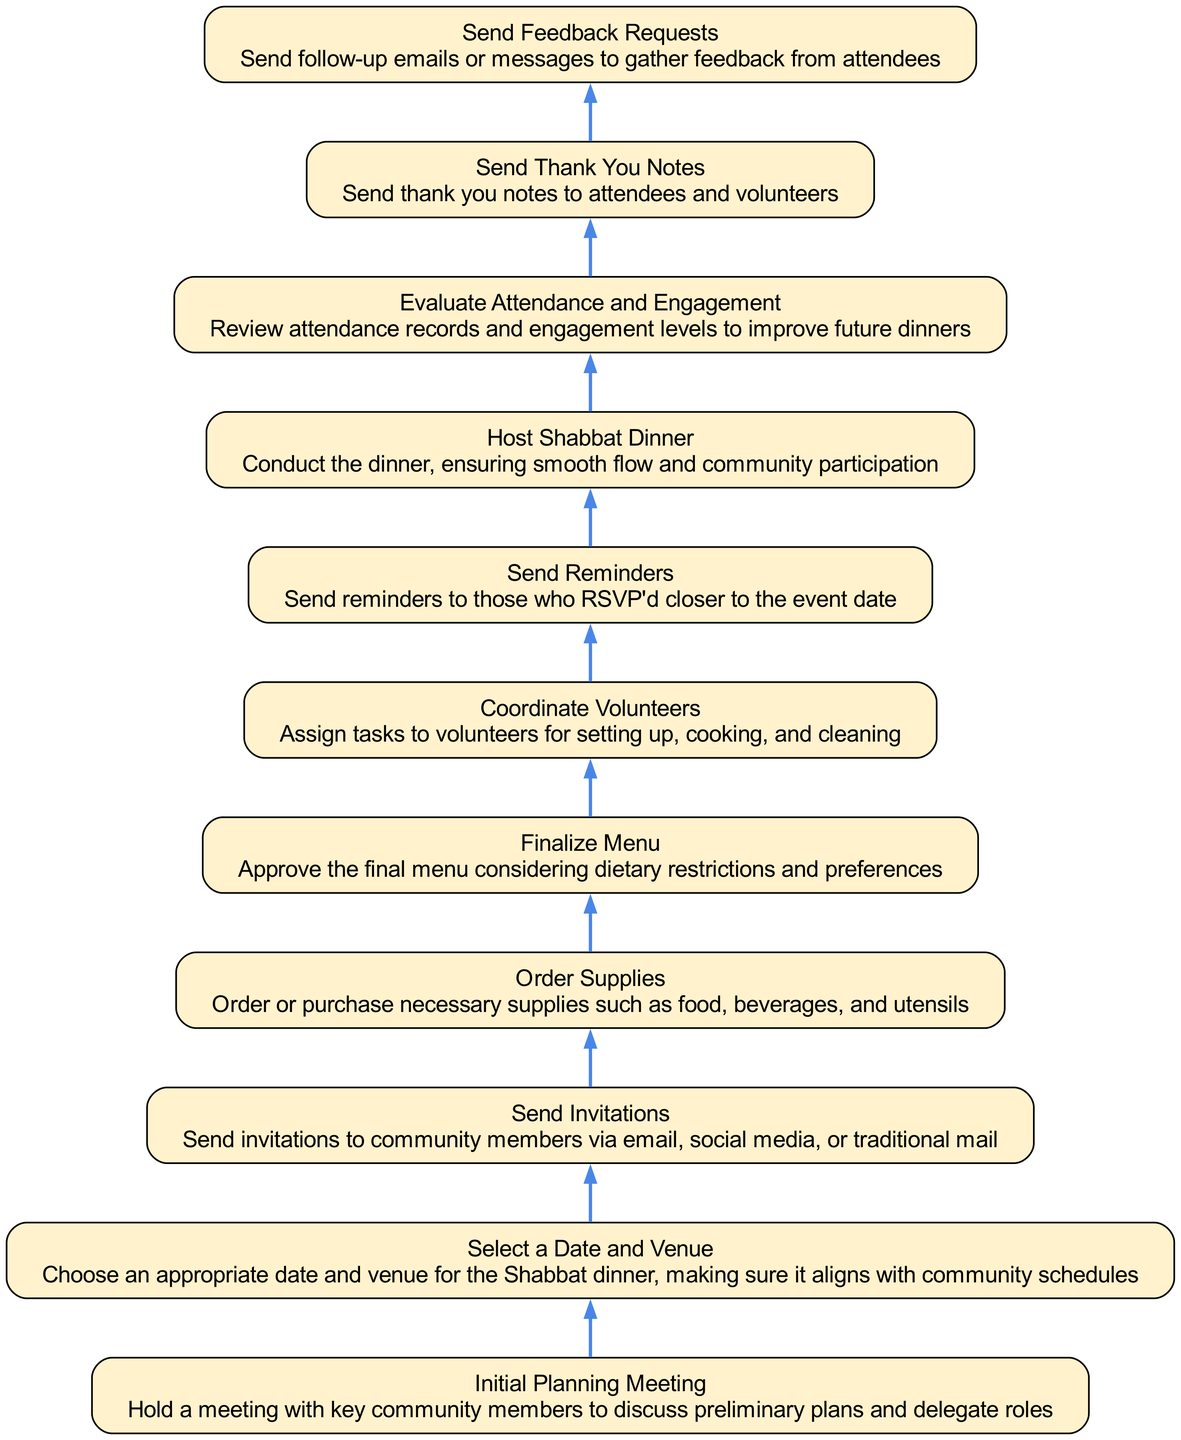What is the first step in the Shabbat Dinner coordination process? The diagram starts with the node "Initial Planning Meeting," which indicates that this is the first step before any other actions can take place.
Answer: Initial Planning Meeting How many nodes are there in total? By counting each unique step listed in the flowchart, there are a total of eleven nodes.
Answer: Eleven What step follows "Send Invitations"? According to the flowchart, "Send Invitations" is followed by "Select a Date and Venue," indicating the next action to take in the process.
Answer: Select a Date and Venue What is the relationship between "Host Shabbat Dinner" and "Send Reminders"? The flowchart shows a directional edge from "Host Shabbat Dinner" to "Send Reminders," indicating that reminders are sent after hosting the dinner.
Answer: Followed by Which step comes after "Order Supplies"? "Order Supplies" leads directly to "Send Invitations," as indicated by the directional flow from one step to the next in the diagram.
Answer: Send Invitations What is the endpoint of the flowchart? The flowchart ends with the node "Initial Planning Meeting," which does not have a subsequent step that follows it, making it the final action in this process.
Answer: Initial Planning Meeting What action is taken to improve future dinners? "Evaluate Attendance and Engagement" is the action taken to gather insights from previous events to enhance future Shabbat dinners.
Answer: Evaluate Attendance and Engagement What task is associated with "Coordinate Volunteers"? "Coordinate Volunteers" involves assigning specific tasks such as setting up, cooking, and cleaning for the Shabbat dinner, as indicated in the node description.
Answer: Assign tasks What does "Send Thank You Notes" follow? The diagram shows that "Send Thank You Notes" follows "Send Feedback Requests," meaning that thank you notes are sent after collecting feedback.
Answer: Send Feedback Requests 